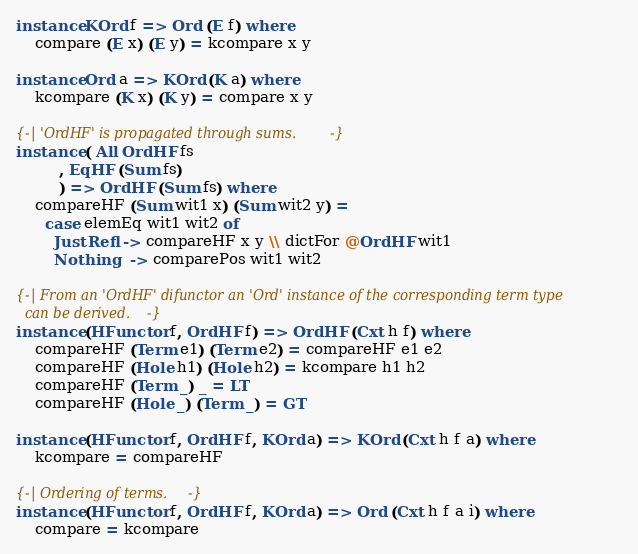<code> <loc_0><loc_0><loc_500><loc_500><_Haskell_>
instance KOrd f => Ord (E f) where
    compare (E x) (E y) = kcompare x y

instance Ord a => KOrd (K a) where
    kcompare (K x) (K y) = compare x y

{-| 'OrdHF' is propagated through sums. -}
instance ( All OrdHF fs
         , EqHF (Sum fs)
         ) => OrdHF (Sum fs) where
    compareHF (Sum wit1 x) (Sum wit2 y) =
      case elemEq wit1 wit2 of
        Just Refl -> compareHF x y \\ dictFor @OrdHF wit1
        Nothing   -> comparePos wit1 wit2

{-| From an 'OrdHF' difunctor an 'Ord' instance of the corresponding term type
  can be derived. -}
instance (HFunctor f, OrdHF f) => OrdHF (Cxt h f) where
    compareHF (Term e1) (Term e2) = compareHF e1 e2
    compareHF (Hole h1) (Hole h2) = kcompare h1 h2
    compareHF (Term _) _ = LT
    compareHF (Hole _) (Term _) = GT

instance (HFunctor f, OrdHF f, KOrd a) => KOrd (Cxt h f a) where
    kcompare = compareHF

{-| Ordering of terms. -}
instance (HFunctor f, OrdHF f, KOrd a) => Ord (Cxt h f a i) where
    compare = kcompare
</code> 